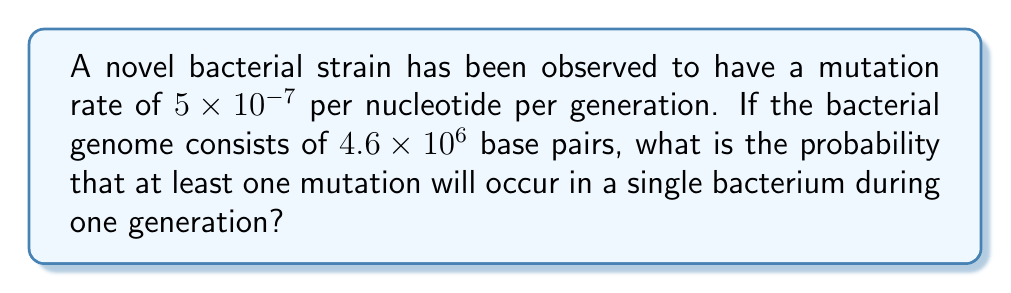What is the answer to this math problem? Let's approach this step-by-step:

1) First, we need to calculate the probability of a mutation occurring at a single nucleotide. This is given as $5 \times 10^{-7}$ per generation.

2) The probability of no mutation occurring at a single nucleotide is therefore:
   $1 - (5 \times 10^{-7}) = 0.9999995$

3) For no mutations to occur in the entire genome, this needs to be true for all nucleotides. The number of nucleotides is $4.6 \times 10^6$.

4) The probability of no mutations in the entire genome is:
   $$(0.9999995)^{4.6 \times 10^6}$$

5) We can simplify this using the exponential function:
   $$e^{(4.6 \times 10^6) \times \ln(0.9999995)}$$

6) Calculating:
   $$e^{(4.6 \times 10^6) \times (-5 \times 10^{-7})} = e^{-2.3} \approx 0.1003$$

7) This is the probability of no mutations occurring. The probability of at least one mutation is the complement of this:

   $$1 - 0.1003 = 0.8997$$

Thus, the probability of at least one mutation occurring is approximately 0.8997 or about 89.97%.
Answer: $0.8997$ or $89.97\%$ 